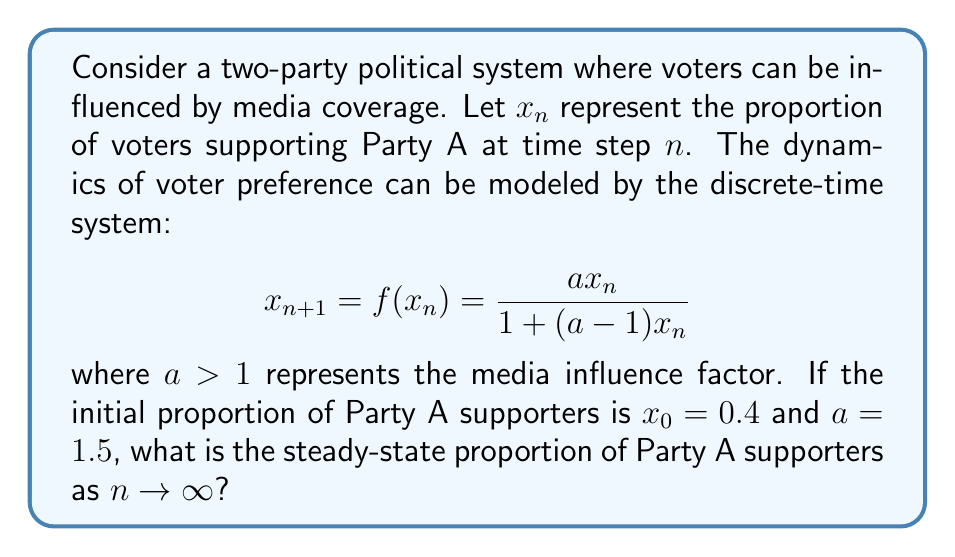Help me with this question. To solve this problem, we'll follow these steps:

1) First, we need to find the fixed points of the system. Fixed points occur when $x_{n+1} = x_n = x^*$. So we solve:

   $$x^* = \frac{ax^*}{1 + (a-1)x^*}$$

2) Simplifying this equation:
   
   $$x^* + (a-1)(x^*)^2 = ax^*$$
   $$(a-1)(x^*)^2 - (a-1)x^* = 0$$
   $$x^*((a-1)x^* - (a-1)) = 0$$

3) Solving this, we get two fixed points:
   
   $$x^* = 0 \text{ or } x^* = 1$$

4) To determine which fixed point is the attractor (steady-state), we need to check the stability. The derivative of $f(x)$ is:

   $$f'(x) = \frac{a}{(1 + (a-1)x)^2}$$

5) For stability, we need $|f'(x^*)| < 1$. Let's check both fixed points:

   At $x^* = 0$: $f'(0) = a = 1.5 > 1$, so this is unstable.
   At $x^* = 1$: $f'(1) = \frac{1}{a} = \frac{2}{3} < 1$, so this is stable.

6) Therefore, the steady-state is $x^* = 1$, regardless of the initial condition (as long as $x_0 \neq 0$).

7) We can verify this by iterating the system a few times:

   $x_1 = \frac{1.5 * 0.4}{1 + 0.5 * 0.4} \approx 0.5455$
   $x_2 \approx 0.6923$
   $x_3 \approx 0.8182$
   $x_4 \approx 0.9091$
   ...

   We can see that $x_n$ is approaching 1.
Answer: 1 